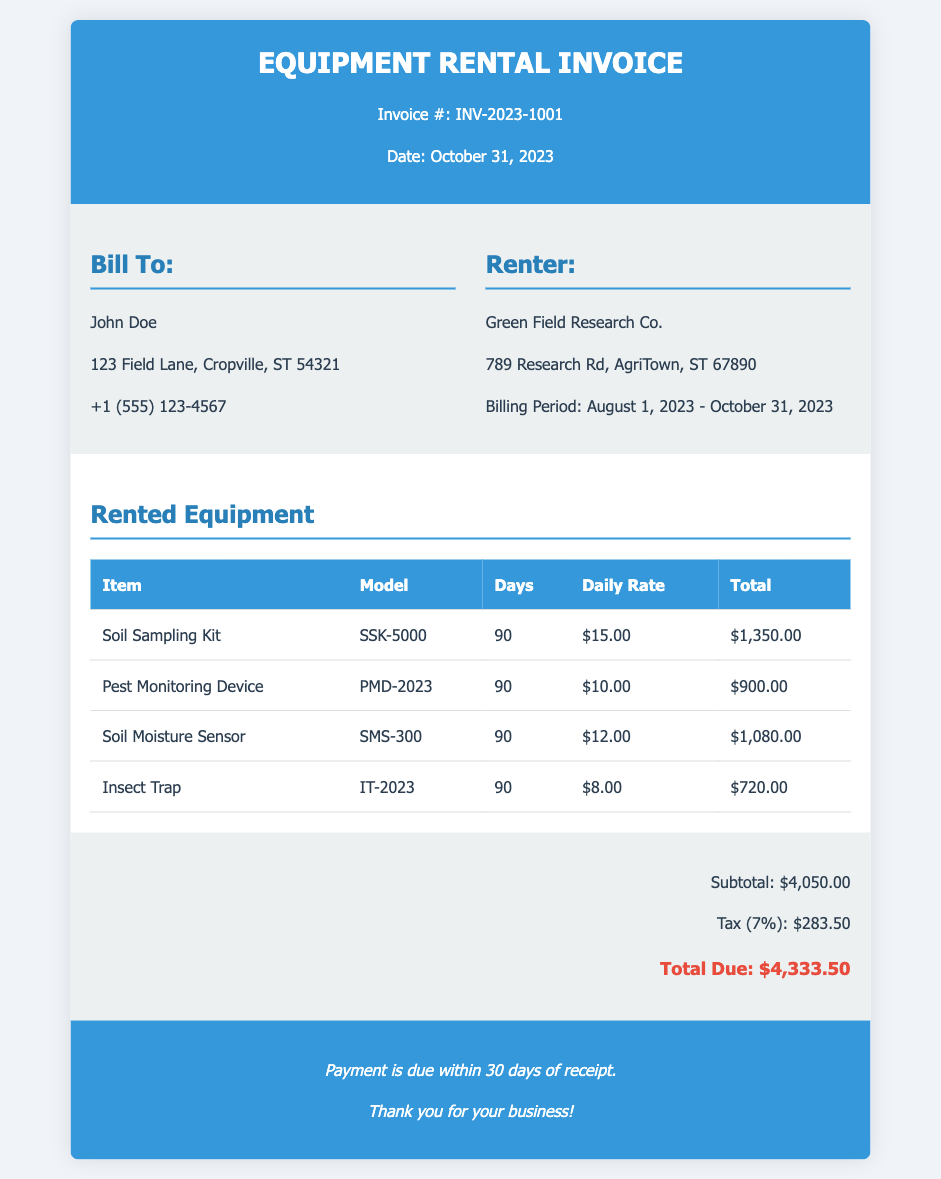What is the invoice number? The invoice number is listed at the top of the document.
Answer: INV-2023-1001 Who is the renter? The renter's name is given in the rental information section of the invoice.
Answer: Green Field Research Co What is the daily rate for the Soil Sampling Kit? The daily rate for the Soil Sampling Kit is mentioned in the rented equipment section.
Answer: $15.00 How many days was the Pest Monitoring Device rented? The number of days rented for the Pest Monitoring Device is stated in the equipment list.
Answer: 90 What is the total due amount? The total due amount is presented in the summary section at the bottom of the invoice.
Answer: $4,333.50 What is the billing period? The billing period is indicated in the rental information of the invoice.
Answer: August 1, 2023 - October 31, 2023 What equipment has the highest total charge? Comparing the totals for all rented equipment, the item with the highest total charge can be identified.
Answer: Soil Sampling Kit What is the tax rate applied in this invoice? The tax rate is specified in the summary section of the document.
Answer: 7% How much was charged for the Soil Moisture Sensor? The total charge for the Soil Moisture Sensor is provided in the equipment list.
Answer: $1,080.00 When is the payment due? The payment due date is mentioned in the footer of the invoice.
Answer: Within 30 days of receipt 